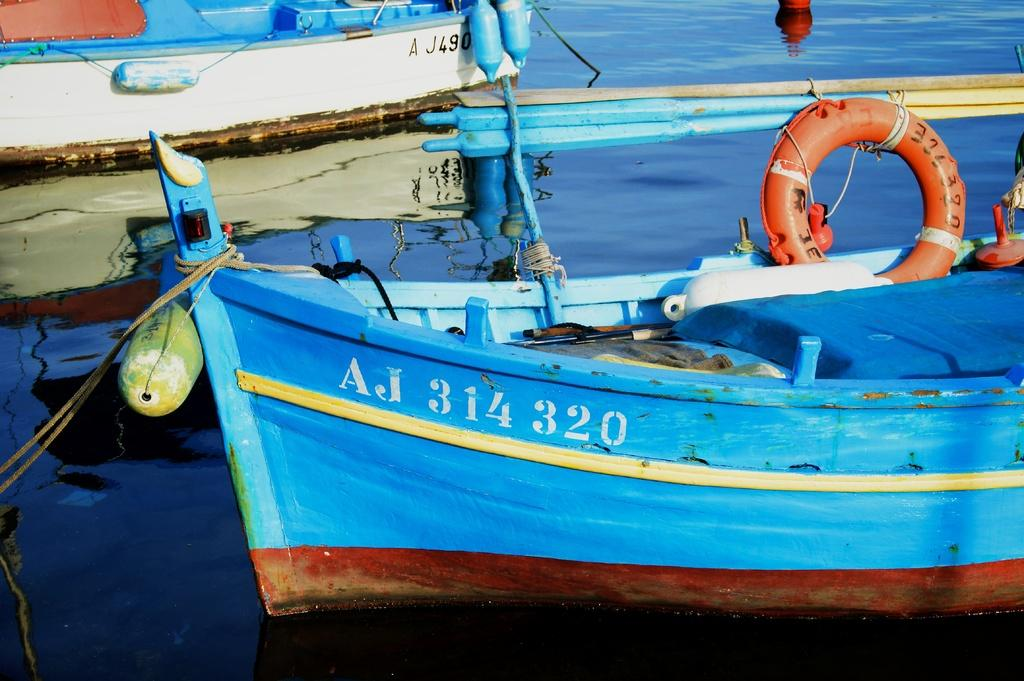<image>
Relay a brief, clear account of the picture shown. Blue boat which says AJ314320 on the front. 